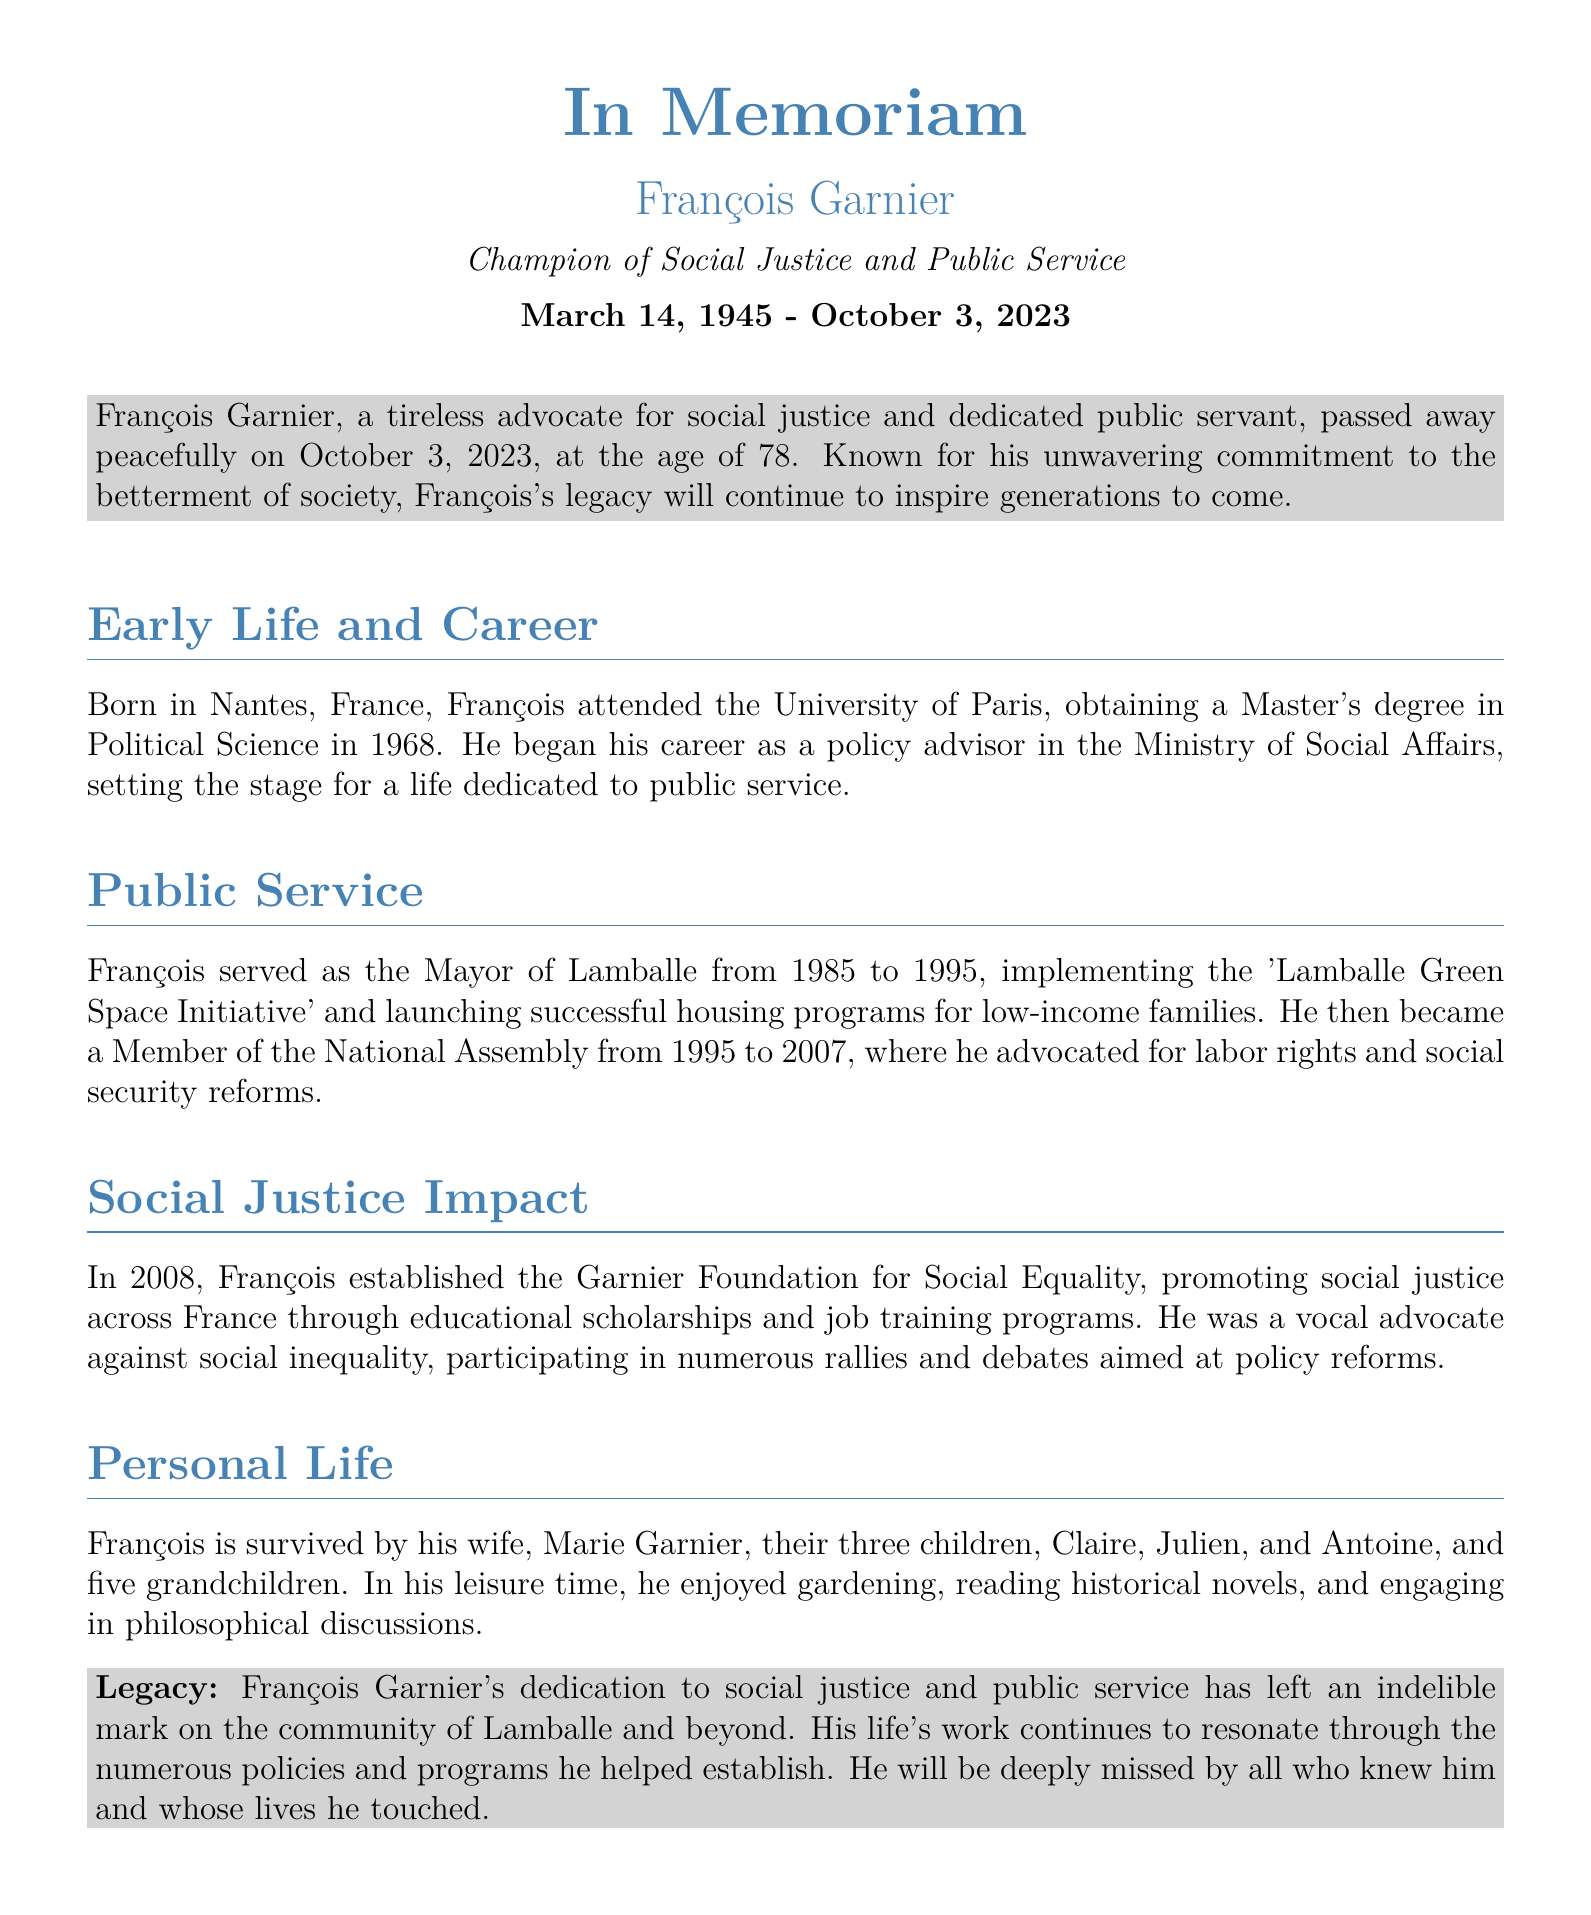What is François Garnier's date of birth? The document specifies that François Garnier was born on March 14, 1945.
Answer: March 14, 1945 What position did François Garnier hold from 1985 to 1995? According to the document, he served as the Mayor of Lamballe during this time.
Answer: Mayor of Lamballe What initiative did François implement as Mayor? The document mentions the 'Lamballe Green Space Initiative' as one of his initiatives.
Answer: Lamballe Green Space Initiative When did François serve as a Member of the National Assembly? He served from 1995 to 2007, as stated in the document.
Answer: 1995 to 2007 What foundation did François establish in 2008? The document states that he established the Garnier Foundation for Social Equality in 2008.
Answer: Garnier Foundation for Social Equality Who is François Garnier survived by? The document lists his wife Marie Garnier and their three children as his survivors.
Answer: Marie Garnier, Claire, Julien, and Antoine What was François Garnier's profession before becoming a Mayor? He began his career as a policy advisor in the Ministry of Social Affairs, according to the document.
Answer: Policy advisor Which social causes did François advocate for? The document indicates he advocated for labor rights and social security reforms, among others.
Answer: Labor rights and social security reforms What hobbies did François enjoy? The document mentions gardening, reading historical novels, and philosophical discussions as his pastimes.
Answer: Gardening, reading historical novels, and philosophical discussions 